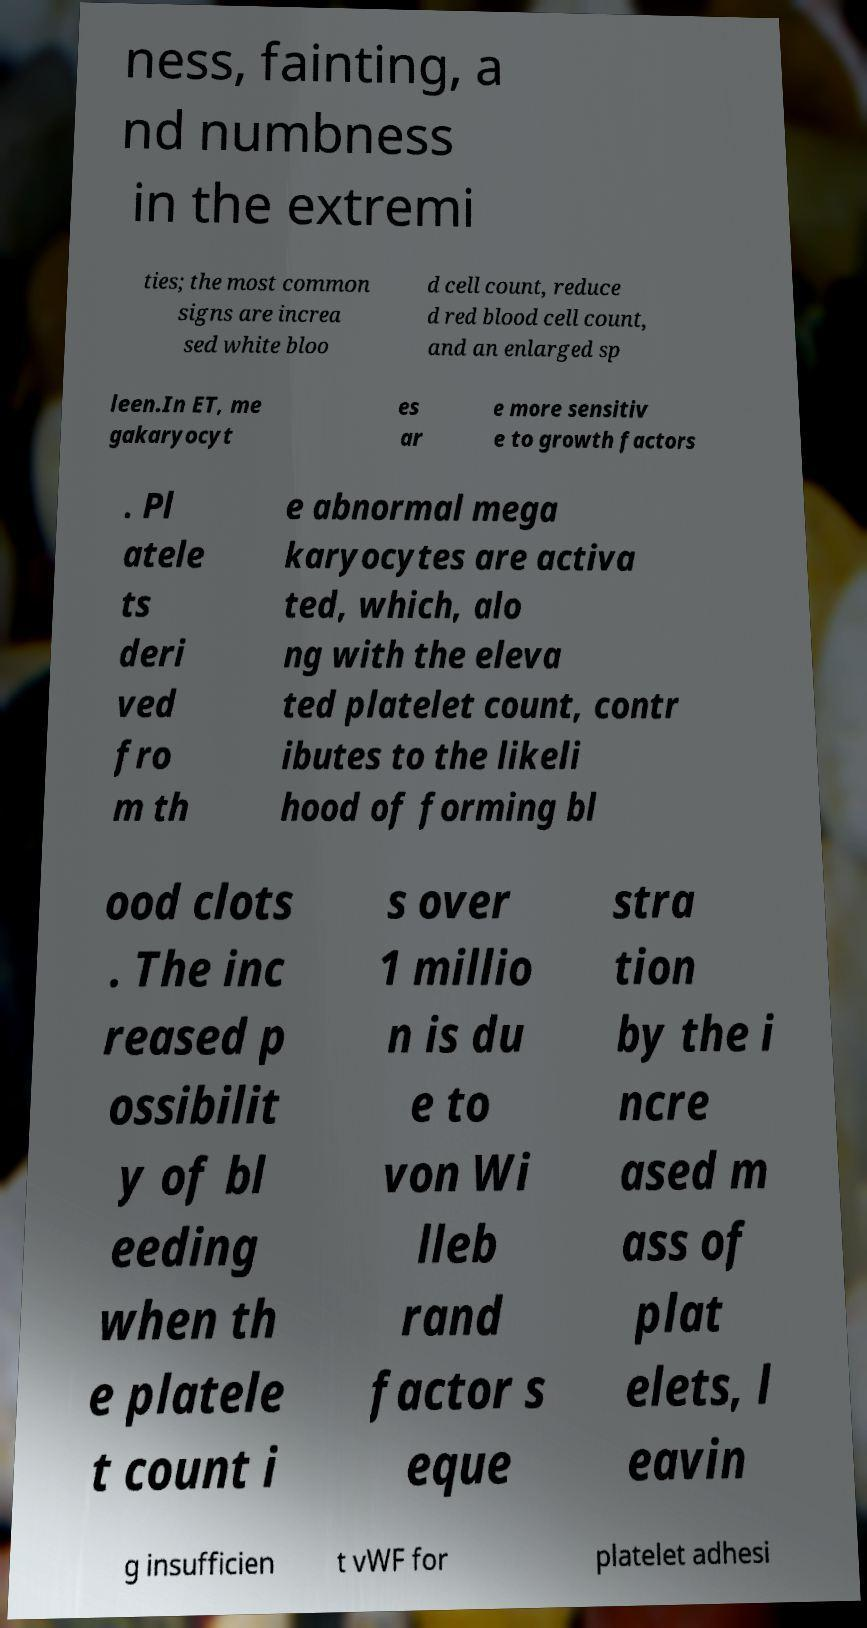Could you extract and type out the text from this image? ness, fainting, a nd numbness in the extremi ties; the most common signs are increa sed white bloo d cell count, reduce d red blood cell count, and an enlarged sp leen.In ET, me gakaryocyt es ar e more sensitiv e to growth factors . Pl atele ts deri ved fro m th e abnormal mega karyocytes are activa ted, which, alo ng with the eleva ted platelet count, contr ibutes to the likeli hood of forming bl ood clots . The inc reased p ossibilit y of bl eeding when th e platele t count i s over 1 millio n is du e to von Wi lleb rand factor s eque stra tion by the i ncre ased m ass of plat elets, l eavin g insufficien t vWF for platelet adhesi 